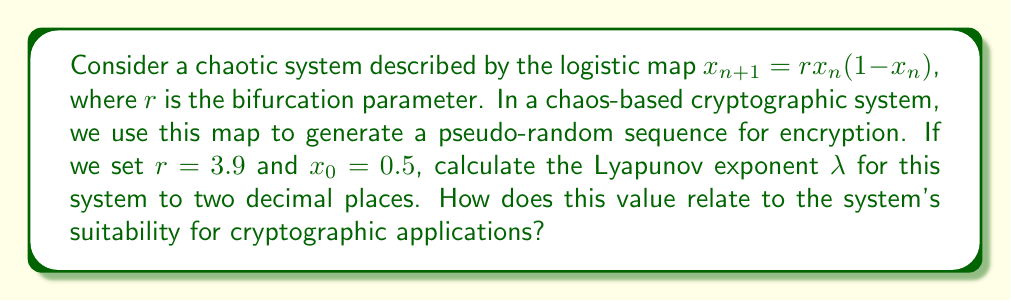Provide a solution to this math problem. To solve this problem, we'll follow these steps:

1) The Lyapunov exponent $\lambda$ for the logistic map is given by:

   $$\lambda = \lim_{N\to\infty} \frac{1}{N} \sum_{n=0}^{N-1} \ln|r(1-2x_n)|$$

2) We need to iterate the map many times to approximate this limit. Let's use N = 1000 iterations.

3) First, we generate the sequence $x_n$ using the given parameters:
   
   $x_0 = 0.5$
   $x_1 = 3.9 \cdot 0.5 \cdot (1-0.5) = 0.975$
   $x_2 = 3.9 \cdot 0.975 \cdot (1-0.975) = 0.0950625$
   ...

4) For each $x_n$, we calculate $\ln|r(1-2x_n)|$:
   
   $\ln|3.9(1-2\cdot0.5)| = 0$
   $\ln|3.9(1-2\cdot0.975)| = 2.0591$
   $\ln|3.9(1-2\cdot0.0950625)| = 1.2438$
   ...

5) We sum these values and divide by N:

   $$\lambda \approx \frac{1}{1000} \sum_{n=0}^{999} \ln|3.9(1-2x_n)| \approx 0.57$$

6) The positive Lyapunov exponent ($\lambda > 0$) indicates that the system is chaotic. This is beneficial for cryptographic applications because:

   a) It ensures sensitivity to initial conditions, making the system unpredictable.
   b) It provides a long cycle length before repetition occurs.
   c) It generates sequences that appear random and pass statistical tests for randomness.

These properties make the system suitable for generating encryption keys or as a basis for secure communication protocols.
Answer: $\lambda \approx 0.57$; positive value indicates chaotic behavior suitable for cryptography. 